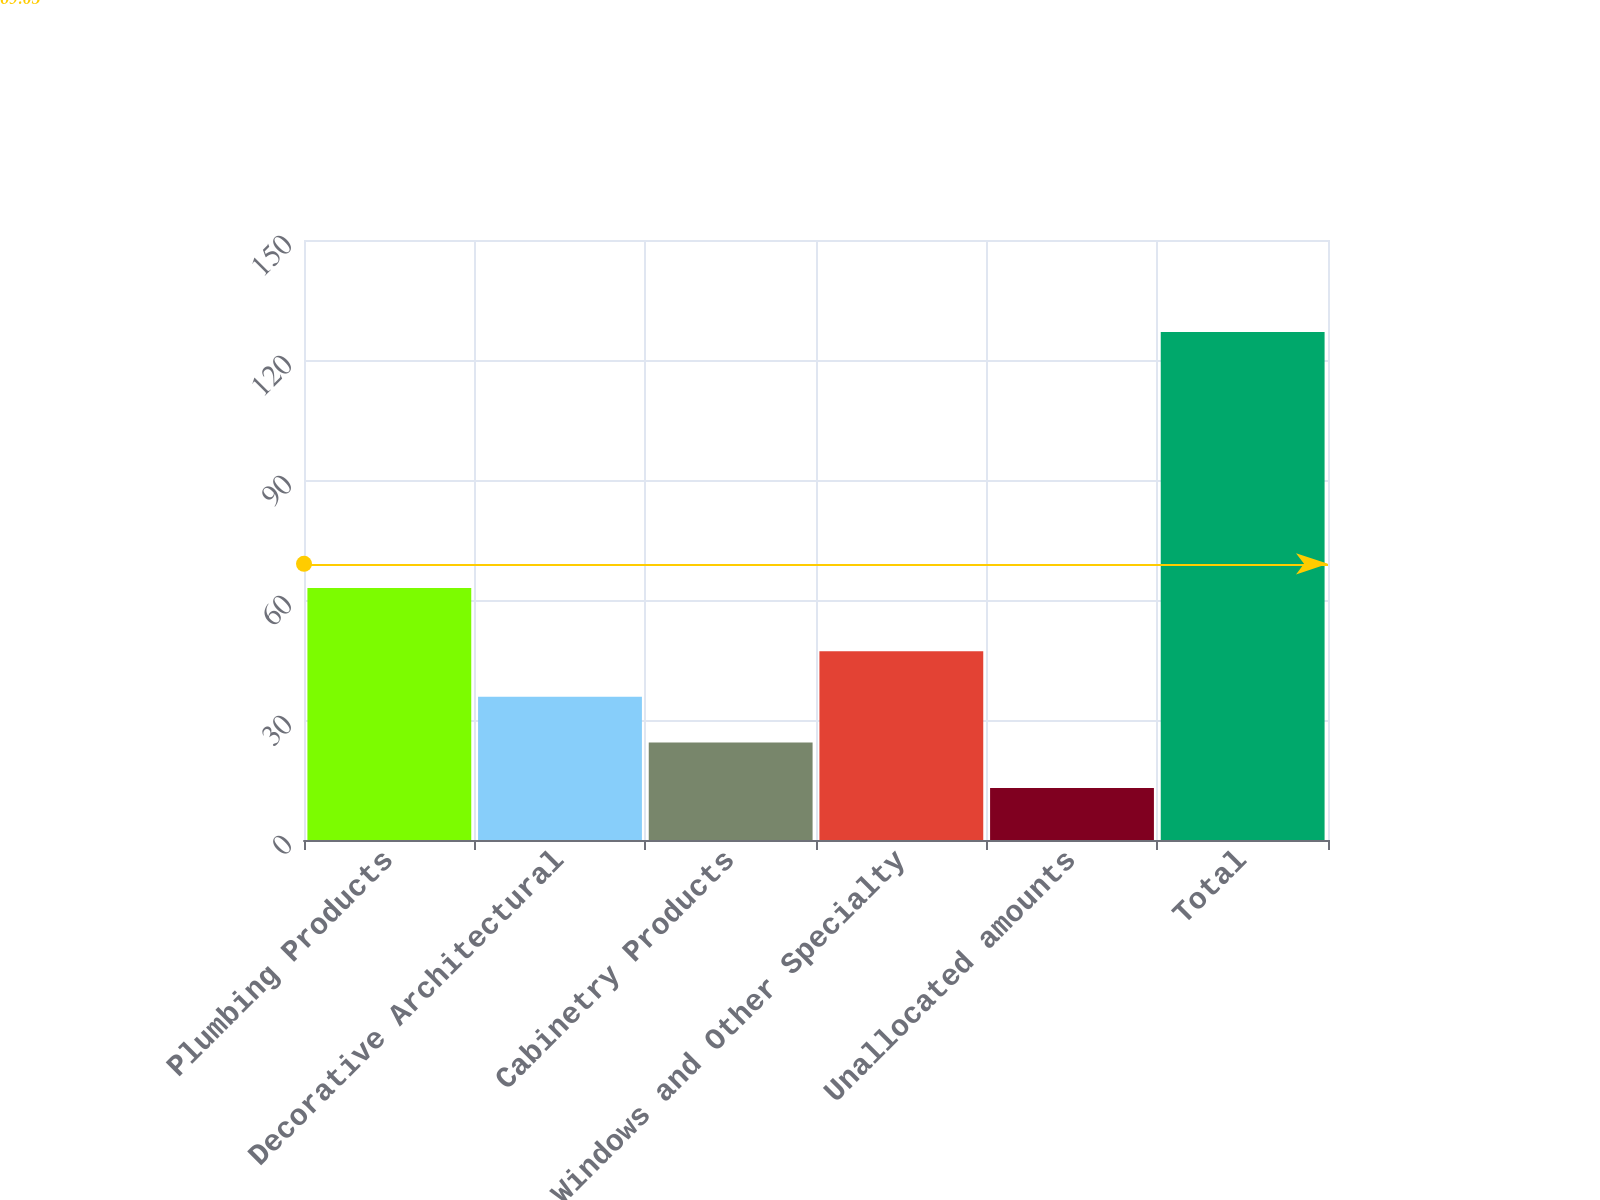<chart> <loc_0><loc_0><loc_500><loc_500><bar_chart><fcel>Plumbing Products<fcel>Decorative Architectural<fcel>Cabinetry Products<fcel>Windows and Other Specialty<fcel>Unallocated amounts<fcel>Total<nl><fcel>63<fcel>35.8<fcel>24.4<fcel>47.2<fcel>13<fcel>127<nl></chart> 